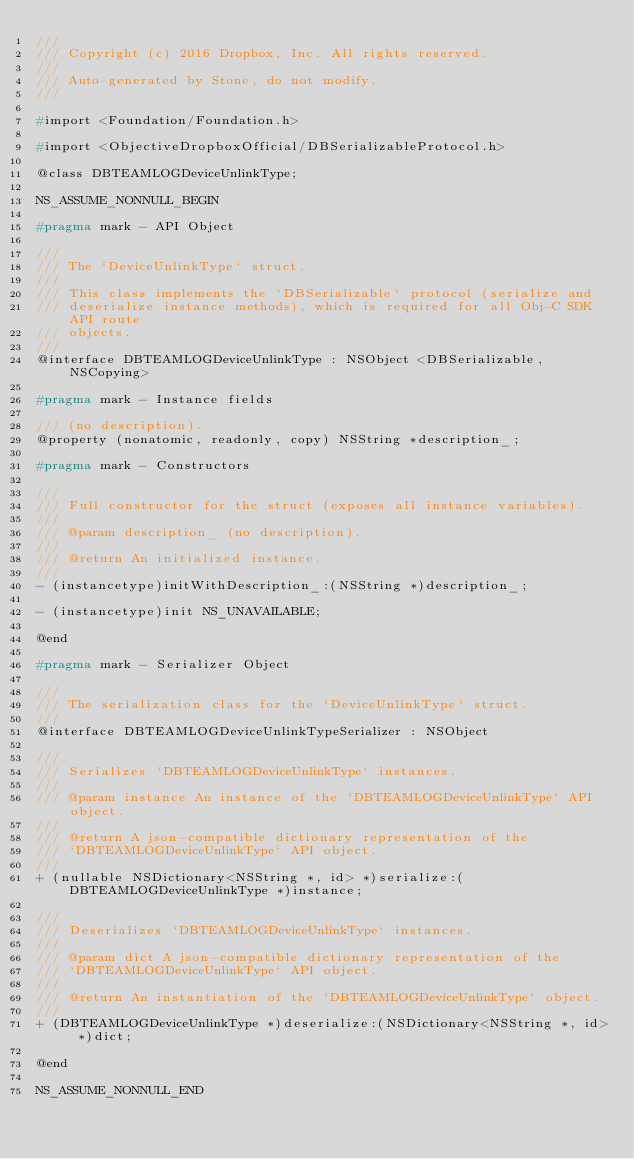Convert code to text. <code><loc_0><loc_0><loc_500><loc_500><_C_>///
/// Copyright (c) 2016 Dropbox, Inc. All rights reserved.
///
/// Auto-generated by Stone, do not modify.
///

#import <Foundation/Foundation.h>

#import <ObjectiveDropboxOfficial/DBSerializableProtocol.h>

@class DBTEAMLOGDeviceUnlinkType;

NS_ASSUME_NONNULL_BEGIN

#pragma mark - API Object

///
/// The `DeviceUnlinkType` struct.
///
/// This class implements the `DBSerializable` protocol (serialize and
/// deserialize instance methods), which is required for all Obj-C SDK API route
/// objects.
///
@interface DBTEAMLOGDeviceUnlinkType : NSObject <DBSerializable, NSCopying>

#pragma mark - Instance fields

/// (no description).
@property (nonatomic, readonly, copy) NSString *description_;

#pragma mark - Constructors

///
/// Full constructor for the struct (exposes all instance variables).
///
/// @param description_ (no description).
///
/// @return An initialized instance.
///
- (instancetype)initWithDescription_:(NSString *)description_;

- (instancetype)init NS_UNAVAILABLE;

@end

#pragma mark - Serializer Object

///
/// The serialization class for the `DeviceUnlinkType` struct.
///
@interface DBTEAMLOGDeviceUnlinkTypeSerializer : NSObject

///
/// Serializes `DBTEAMLOGDeviceUnlinkType` instances.
///
/// @param instance An instance of the `DBTEAMLOGDeviceUnlinkType` API object.
///
/// @return A json-compatible dictionary representation of the
/// `DBTEAMLOGDeviceUnlinkType` API object.
///
+ (nullable NSDictionary<NSString *, id> *)serialize:(DBTEAMLOGDeviceUnlinkType *)instance;

///
/// Deserializes `DBTEAMLOGDeviceUnlinkType` instances.
///
/// @param dict A json-compatible dictionary representation of the
/// `DBTEAMLOGDeviceUnlinkType` API object.
///
/// @return An instantiation of the `DBTEAMLOGDeviceUnlinkType` object.
///
+ (DBTEAMLOGDeviceUnlinkType *)deserialize:(NSDictionary<NSString *, id> *)dict;

@end

NS_ASSUME_NONNULL_END
</code> 